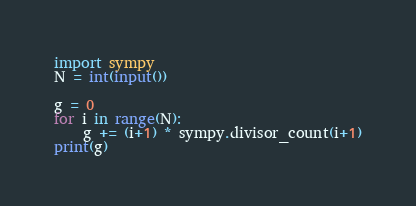<code> <loc_0><loc_0><loc_500><loc_500><_Python_>import sympy
N = int(input())

g = 0
for i in range(N):
    g += (i+1) * sympy.divisor_count(i+1)
print(g)</code> 